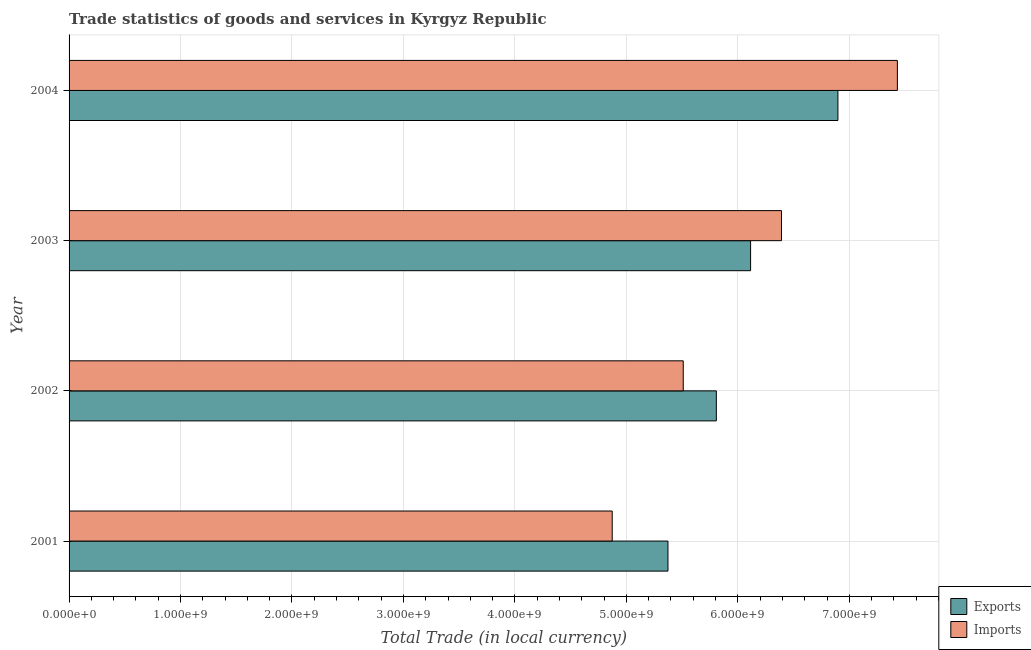How many different coloured bars are there?
Provide a succinct answer. 2. How many groups of bars are there?
Offer a very short reply. 4. Are the number of bars per tick equal to the number of legend labels?
Your response must be concise. Yes. Are the number of bars on each tick of the Y-axis equal?
Offer a terse response. Yes. What is the label of the 2nd group of bars from the top?
Your response must be concise. 2003. In how many cases, is the number of bars for a given year not equal to the number of legend labels?
Give a very brief answer. 0. What is the export of goods and services in 2001?
Give a very brief answer. 5.37e+09. Across all years, what is the maximum export of goods and services?
Provide a short and direct response. 6.90e+09. Across all years, what is the minimum export of goods and services?
Offer a terse response. 5.37e+09. In which year was the export of goods and services maximum?
Ensure brevity in your answer.  2004. What is the total imports of goods and services in the graph?
Give a very brief answer. 2.42e+1. What is the difference between the export of goods and services in 2002 and that in 2003?
Offer a terse response. -3.07e+08. What is the difference between the export of goods and services in 2002 and the imports of goods and services in 2003?
Your answer should be very brief. -5.84e+08. What is the average export of goods and services per year?
Your response must be concise. 6.05e+09. In the year 2002, what is the difference between the export of goods and services and imports of goods and services?
Ensure brevity in your answer.  2.97e+08. In how many years, is the export of goods and services greater than 1600000000 LCU?
Give a very brief answer. 4. What is the ratio of the export of goods and services in 2002 to that in 2003?
Give a very brief answer. 0.95. Is the imports of goods and services in 2001 less than that in 2004?
Provide a short and direct response. Yes. Is the difference between the imports of goods and services in 2002 and 2004 greater than the difference between the export of goods and services in 2002 and 2004?
Offer a very short reply. No. What is the difference between the highest and the second highest imports of goods and services?
Your answer should be compact. 1.04e+09. What is the difference between the highest and the lowest export of goods and services?
Your answer should be compact. 1.52e+09. What does the 2nd bar from the top in 2002 represents?
Your answer should be very brief. Exports. What does the 2nd bar from the bottom in 2003 represents?
Provide a succinct answer. Imports. How many bars are there?
Give a very brief answer. 8. Are the values on the major ticks of X-axis written in scientific E-notation?
Provide a succinct answer. Yes. Does the graph contain any zero values?
Your answer should be compact. No. Does the graph contain grids?
Provide a short and direct response. Yes. Where does the legend appear in the graph?
Ensure brevity in your answer.  Bottom right. How many legend labels are there?
Keep it short and to the point. 2. How are the legend labels stacked?
Provide a short and direct response. Vertical. What is the title of the graph?
Give a very brief answer. Trade statistics of goods and services in Kyrgyz Republic. Does "International Visitors" appear as one of the legend labels in the graph?
Your response must be concise. No. What is the label or title of the X-axis?
Provide a succinct answer. Total Trade (in local currency). What is the Total Trade (in local currency) of Exports in 2001?
Make the answer very short. 5.37e+09. What is the Total Trade (in local currency) of Imports in 2001?
Offer a terse response. 4.87e+09. What is the Total Trade (in local currency) of Exports in 2002?
Offer a terse response. 5.81e+09. What is the Total Trade (in local currency) in Imports in 2002?
Keep it short and to the point. 5.51e+09. What is the Total Trade (in local currency) of Exports in 2003?
Offer a very short reply. 6.11e+09. What is the Total Trade (in local currency) of Imports in 2003?
Ensure brevity in your answer.  6.39e+09. What is the Total Trade (in local currency) of Exports in 2004?
Your answer should be compact. 6.90e+09. What is the Total Trade (in local currency) of Imports in 2004?
Keep it short and to the point. 7.43e+09. Across all years, what is the maximum Total Trade (in local currency) of Exports?
Offer a terse response. 6.90e+09. Across all years, what is the maximum Total Trade (in local currency) of Imports?
Give a very brief answer. 7.43e+09. Across all years, what is the minimum Total Trade (in local currency) in Exports?
Keep it short and to the point. 5.37e+09. Across all years, what is the minimum Total Trade (in local currency) of Imports?
Give a very brief answer. 4.87e+09. What is the total Total Trade (in local currency) of Exports in the graph?
Your response must be concise. 2.42e+1. What is the total Total Trade (in local currency) of Imports in the graph?
Your answer should be very brief. 2.42e+1. What is the difference between the Total Trade (in local currency) of Exports in 2001 and that in 2002?
Offer a very short reply. -4.34e+08. What is the difference between the Total Trade (in local currency) of Imports in 2001 and that in 2002?
Your answer should be very brief. -6.37e+08. What is the difference between the Total Trade (in local currency) of Exports in 2001 and that in 2003?
Give a very brief answer. -7.41e+08. What is the difference between the Total Trade (in local currency) in Imports in 2001 and that in 2003?
Offer a very short reply. -1.52e+09. What is the difference between the Total Trade (in local currency) in Exports in 2001 and that in 2004?
Provide a succinct answer. -1.52e+09. What is the difference between the Total Trade (in local currency) of Imports in 2001 and that in 2004?
Provide a succinct answer. -2.56e+09. What is the difference between the Total Trade (in local currency) of Exports in 2002 and that in 2003?
Make the answer very short. -3.07e+08. What is the difference between the Total Trade (in local currency) of Imports in 2002 and that in 2003?
Make the answer very short. -8.81e+08. What is the difference between the Total Trade (in local currency) in Exports in 2002 and that in 2004?
Provide a short and direct response. -1.09e+09. What is the difference between the Total Trade (in local currency) in Imports in 2002 and that in 2004?
Your response must be concise. -1.92e+09. What is the difference between the Total Trade (in local currency) in Exports in 2003 and that in 2004?
Offer a terse response. -7.84e+08. What is the difference between the Total Trade (in local currency) of Imports in 2003 and that in 2004?
Offer a very short reply. -1.04e+09. What is the difference between the Total Trade (in local currency) of Exports in 2001 and the Total Trade (in local currency) of Imports in 2002?
Ensure brevity in your answer.  -1.37e+08. What is the difference between the Total Trade (in local currency) in Exports in 2001 and the Total Trade (in local currency) in Imports in 2003?
Keep it short and to the point. -1.02e+09. What is the difference between the Total Trade (in local currency) in Exports in 2001 and the Total Trade (in local currency) in Imports in 2004?
Provide a short and direct response. -2.06e+09. What is the difference between the Total Trade (in local currency) in Exports in 2002 and the Total Trade (in local currency) in Imports in 2003?
Your response must be concise. -5.84e+08. What is the difference between the Total Trade (in local currency) of Exports in 2002 and the Total Trade (in local currency) of Imports in 2004?
Provide a short and direct response. -1.62e+09. What is the difference between the Total Trade (in local currency) in Exports in 2003 and the Total Trade (in local currency) in Imports in 2004?
Provide a succinct answer. -1.32e+09. What is the average Total Trade (in local currency) in Exports per year?
Offer a very short reply. 6.05e+09. What is the average Total Trade (in local currency) of Imports per year?
Provide a short and direct response. 6.05e+09. In the year 2001, what is the difference between the Total Trade (in local currency) in Exports and Total Trade (in local currency) in Imports?
Your answer should be compact. 5.00e+08. In the year 2002, what is the difference between the Total Trade (in local currency) of Exports and Total Trade (in local currency) of Imports?
Your answer should be compact. 2.97e+08. In the year 2003, what is the difference between the Total Trade (in local currency) in Exports and Total Trade (in local currency) in Imports?
Provide a short and direct response. -2.77e+08. In the year 2004, what is the difference between the Total Trade (in local currency) in Exports and Total Trade (in local currency) in Imports?
Ensure brevity in your answer.  -5.33e+08. What is the ratio of the Total Trade (in local currency) of Exports in 2001 to that in 2002?
Provide a short and direct response. 0.93. What is the ratio of the Total Trade (in local currency) of Imports in 2001 to that in 2002?
Give a very brief answer. 0.88. What is the ratio of the Total Trade (in local currency) of Exports in 2001 to that in 2003?
Ensure brevity in your answer.  0.88. What is the ratio of the Total Trade (in local currency) in Imports in 2001 to that in 2003?
Make the answer very short. 0.76. What is the ratio of the Total Trade (in local currency) in Exports in 2001 to that in 2004?
Your answer should be compact. 0.78. What is the ratio of the Total Trade (in local currency) of Imports in 2001 to that in 2004?
Offer a very short reply. 0.66. What is the ratio of the Total Trade (in local currency) of Exports in 2002 to that in 2003?
Provide a short and direct response. 0.95. What is the ratio of the Total Trade (in local currency) in Imports in 2002 to that in 2003?
Provide a succinct answer. 0.86. What is the ratio of the Total Trade (in local currency) of Exports in 2002 to that in 2004?
Keep it short and to the point. 0.84. What is the ratio of the Total Trade (in local currency) of Imports in 2002 to that in 2004?
Your response must be concise. 0.74. What is the ratio of the Total Trade (in local currency) in Exports in 2003 to that in 2004?
Offer a very short reply. 0.89. What is the ratio of the Total Trade (in local currency) of Imports in 2003 to that in 2004?
Provide a short and direct response. 0.86. What is the difference between the highest and the second highest Total Trade (in local currency) of Exports?
Your response must be concise. 7.84e+08. What is the difference between the highest and the second highest Total Trade (in local currency) of Imports?
Your answer should be very brief. 1.04e+09. What is the difference between the highest and the lowest Total Trade (in local currency) in Exports?
Ensure brevity in your answer.  1.52e+09. What is the difference between the highest and the lowest Total Trade (in local currency) in Imports?
Your response must be concise. 2.56e+09. 